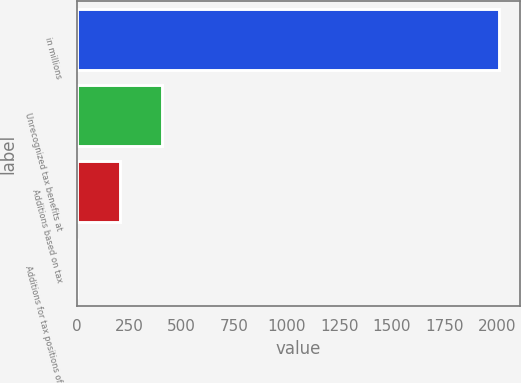Convert chart to OTSL. <chart><loc_0><loc_0><loc_500><loc_500><bar_chart><fcel>in millions<fcel>Unrecognized tax benefits at<fcel>Additions based on tax<fcel>Additions for tax positions of<nl><fcel>2010<fcel>405.2<fcel>204.6<fcel>4<nl></chart> 